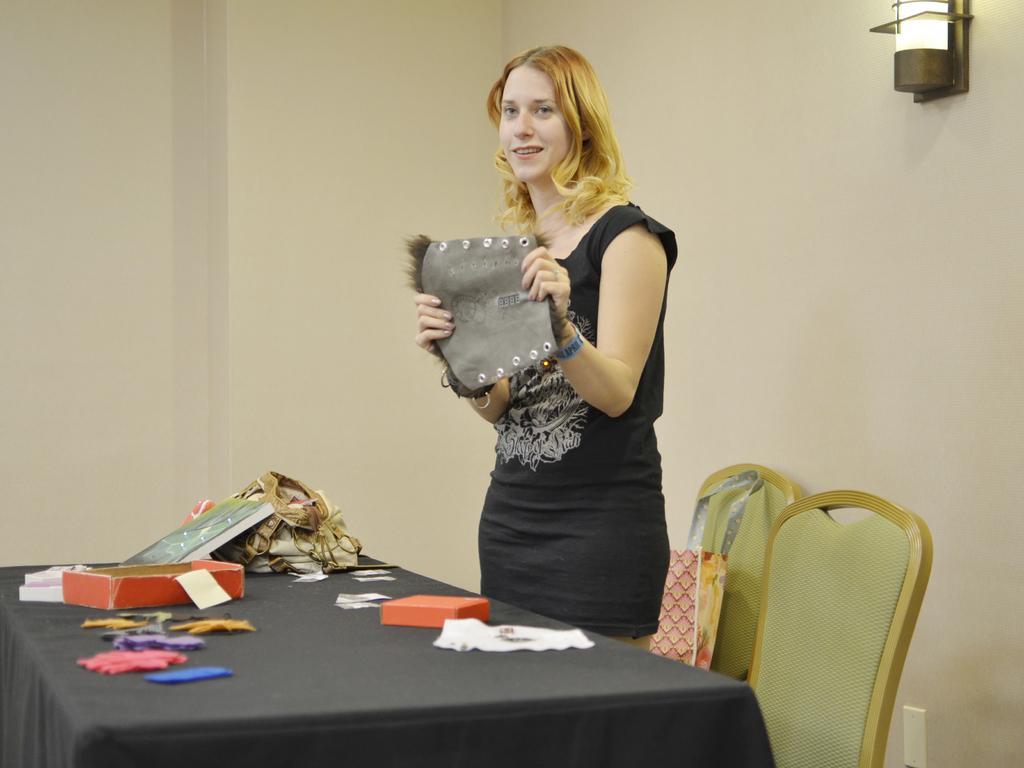Could you give a brief overview of what you see in this image? In this image I can see a woman is holding an object in her hands. I can also see there is a table and few chairs. On the table we have some other objects on it. 